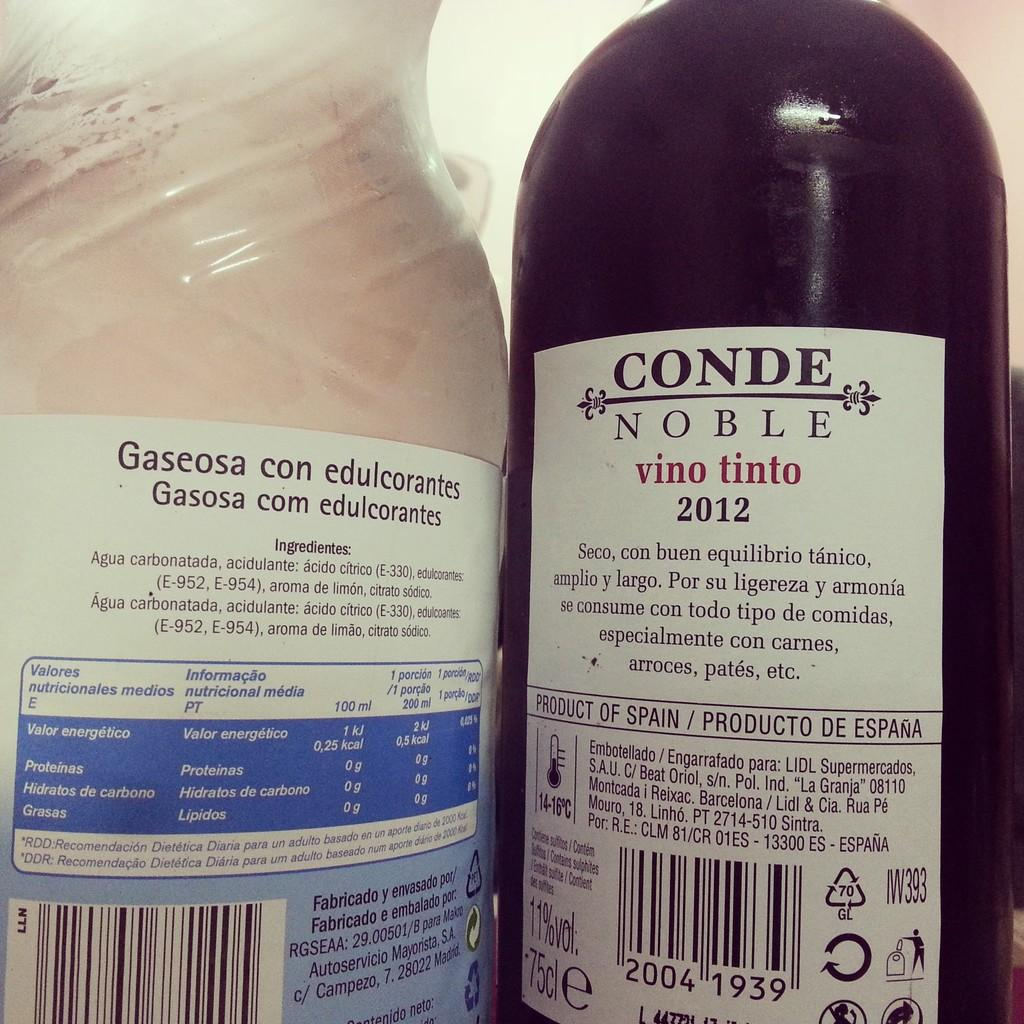<image>
Share a concise interpretation of the image provided. Bottle with a white label that says the year 2012 on it. 